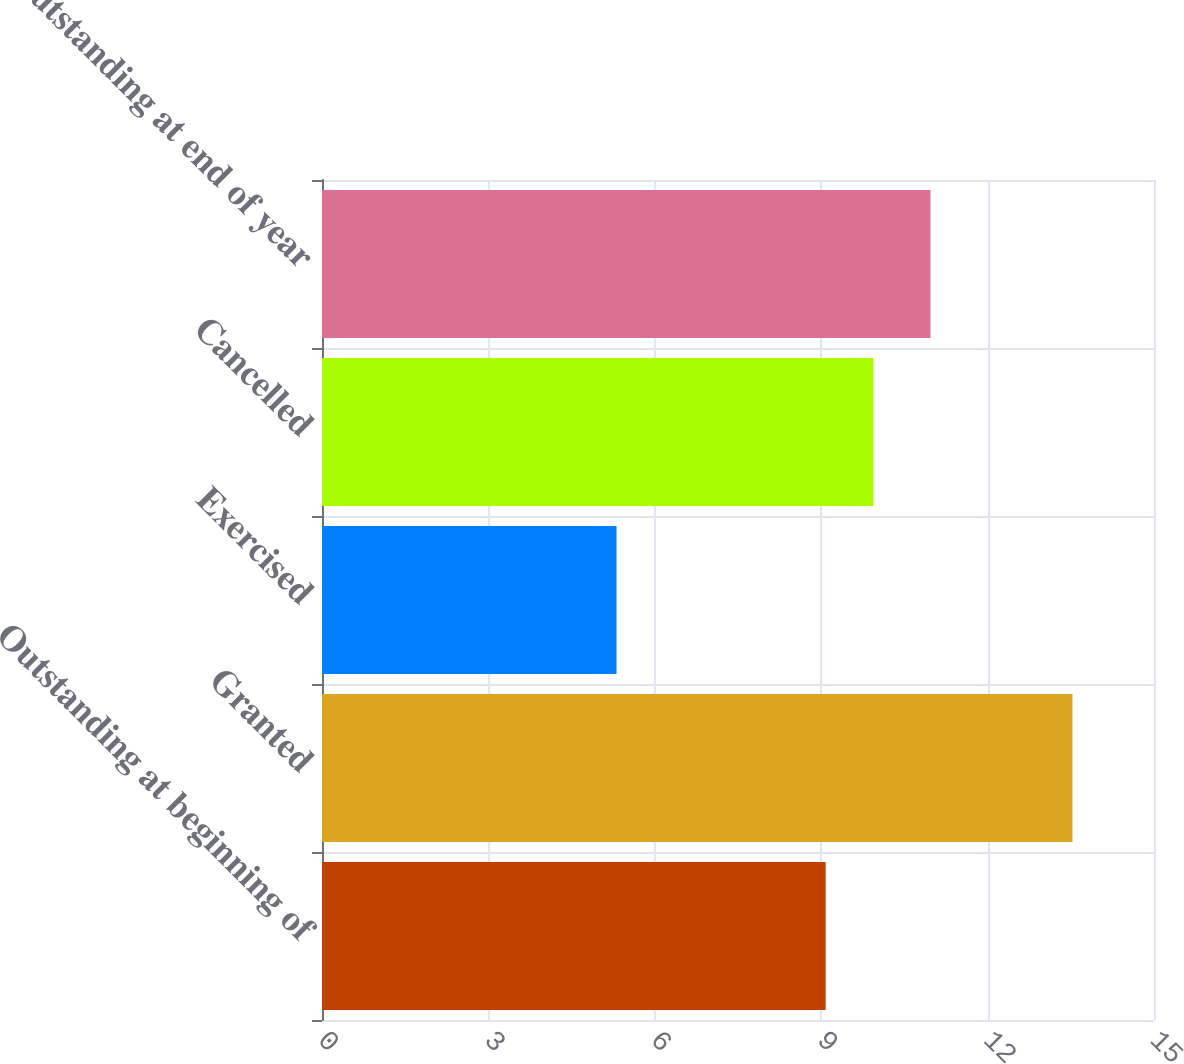Convert chart to OTSL. <chart><loc_0><loc_0><loc_500><loc_500><bar_chart><fcel>Outstanding at beginning of<fcel>Granted<fcel>Exercised<fcel>Cancelled<fcel>Outstanding at end of year<nl><fcel>9.08<fcel>13.53<fcel>5.31<fcel>9.94<fcel>10.97<nl></chart> 